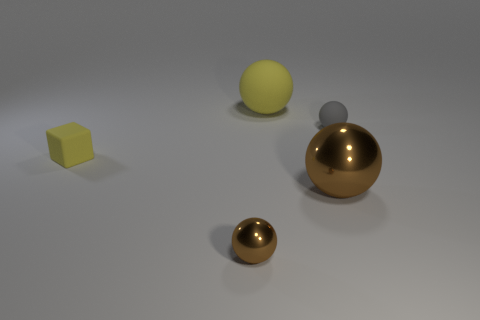How would you describe the lighting in the scene? The lighting in the scene is diffused and soft, coming from above. Shadows are cast directly underneath the objects, indicating a single light source without harsh directions. This creates a calm and evenly lit atmosphere with a gentle contrast between light and shadow. 